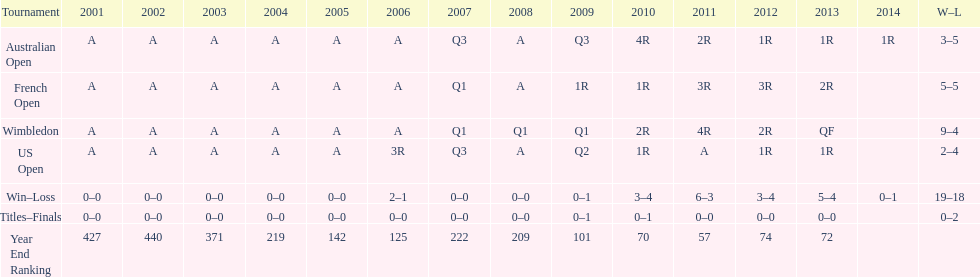What is the difference in wins between wimbledon and the us open for this player? 7. Could you parse the entire table? {'header': ['Tournament', '2001', '2002', '2003', '2004', '2005', '2006', '2007', '2008', '2009', '2010', '2011', '2012', '2013', '2014', 'W–L'], 'rows': [['Australian Open', 'A', 'A', 'A', 'A', 'A', 'A', 'Q3', 'A', 'Q3', '4R', '2R', '1R', '1R', '1R', '3–5'], ['French Open', 'A', 'A', 'A', 'A', 'A', 'A', 'Q1', 'A', '1R', '1R', '3R', '3R', '2R', '', '5–5'], ['Wimbledon', 'A', 'A', 'A', 'A', 'A', 'A', 'Q1', 'Q1', 'Q1', '2R', '4R', '2R', 'QF', '', '9–4'], ['US Open', 'A', 'A', 'A', 'A', 'A', '3R', 'Q3', 'A', 'Q2', '1R', 'A', '1R', '1R', '', '2–4'], ['Win–Loss', '0–0', '0–0', '0–0', '0–0', '0–0', '2–1', '0–0', '0–0', '0–1', '3–4', '6–3', '3–4', '5–4', '0–1', '19–18'], ['Titles–Finals', '0–0', '0–0', '0–0', '0–0', '0–0', '0–0', '0–0', '0–0', '0–1', '0–1', '0–0', '0–0', '0–0', '', '0–2'], ['Year End Ranking', '427', '440', '371', '219', '142', '125', '222', '209', '101', '70', '57', '74', '72', '', '']]} 